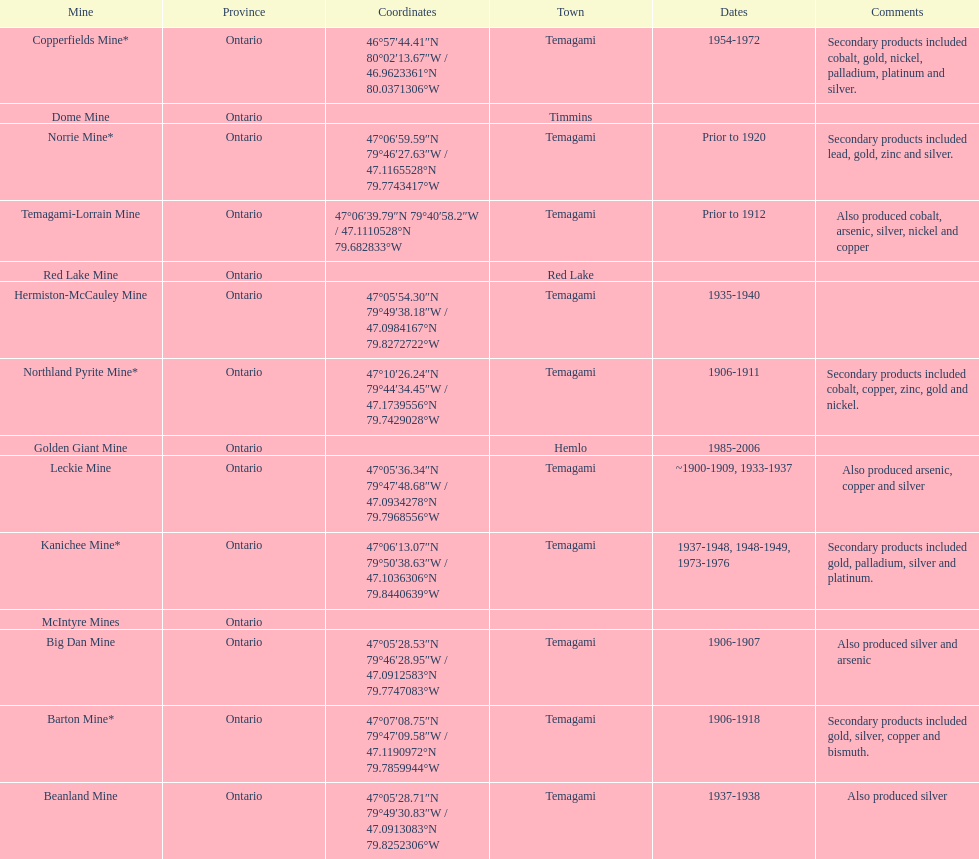What province is the town of temagami? Ontario. 